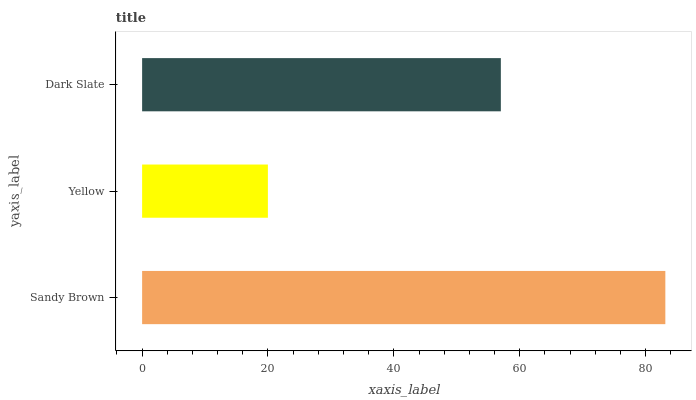Is Yellow the minimum?
Answer yes or no. Yes. Is Sandy Brown the maximum?
Answer yes or no. Yes. Is Dark Slate the minimum?
Answer yes or no. No. Is Dark Slate the maximum?
Answer yes or no. No. Is Dark Slate greater than Yellow?
Answer yes or no. Yes. Is Yellow less than Dark Slate?
Answer yes or no. Yes. Is Yellow greater than Dark Slate?
Answer yes or no. No. Is Dark Slate less than Yellow?
Answer yes or no. No. Is Dark Slate the high median?
Answer yes or no. Yes. Is Dark Slate the low median?
Answer yes or no. Yes. Is Yellow the high median?
Answer yes or no. No. Is Yellow the low median?
Answer yes or no. No. 